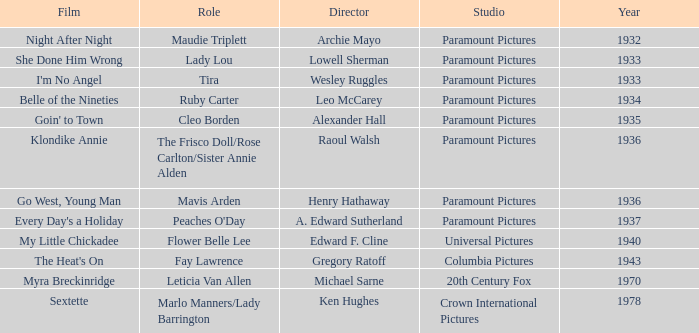Could you parse the entire table as a dict? {'header': ['Film', 'Role', 'Director', 'Studio', 'Year'], 'rows': [['Night After Night', 'Maudie Triplett', 'Archie Mayo', 'Paramount Pictures', '1932'], ['She Done Him Wrong', 'Lady Lou', 'Lowell Sherman', 'Paramount Pictures', '1933'], ["I'm No Angel", 'Tira', 'Wesley Ruggles', 'Paramount Pictures', '1933'], ['Belle of the Nineties', 'Ruby Carter', 'Leo McCarey', 'Paramount Pictures', '1934'], ["Goin' to Town", 'Cleo Borden', 'Alexander Hall', 'Paramount Pictures', '1935'], ['Klondike Annie', 'The Frisco Doll/Rose Carlton/Sister Annie Alden', 'Raoul Walsh', 'Paramount Pictures', '1936'], ['Go West, Young Man', 'Mavis Arden', 'Henry Hathaway', 'Paramount Pictures', '1936'], ["Every Day's a Holiday", "Peaches O'Day", 'A. Edward Sutherland', 'Paramount Pictures', '1937'], ['My Little Chickadee', 'Flower Belle Lee', 'Edward F. Cline', 'Universal Pictures', '1940'], ["The Heat's On", 'Fay Lawrence', 'Gregory Ratoff', 'Columbia Pictures', '1943'], ['Myra Breckinridge', 'Leticia Van Allen', 'Michael Sarne', '20th Century Fox', '1970'], ['Sextette', 'Marlo Manners/Lady Barrington', 'Ken Hughes', 'Crown International Pictures', '1978']]} What is the Studio of the Film with Director Gregory Ratoff after 1933? Columbia Pictures. 